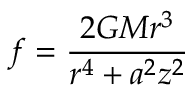Convert formula to latex. <formula><loc_0><loc_0><loc_500><loc_500>f = { \frac { 2 G M r ^ { 3 } } { r ^ { 4 } + a ^ { 2 } z ^ { 2 } } }</formula> 